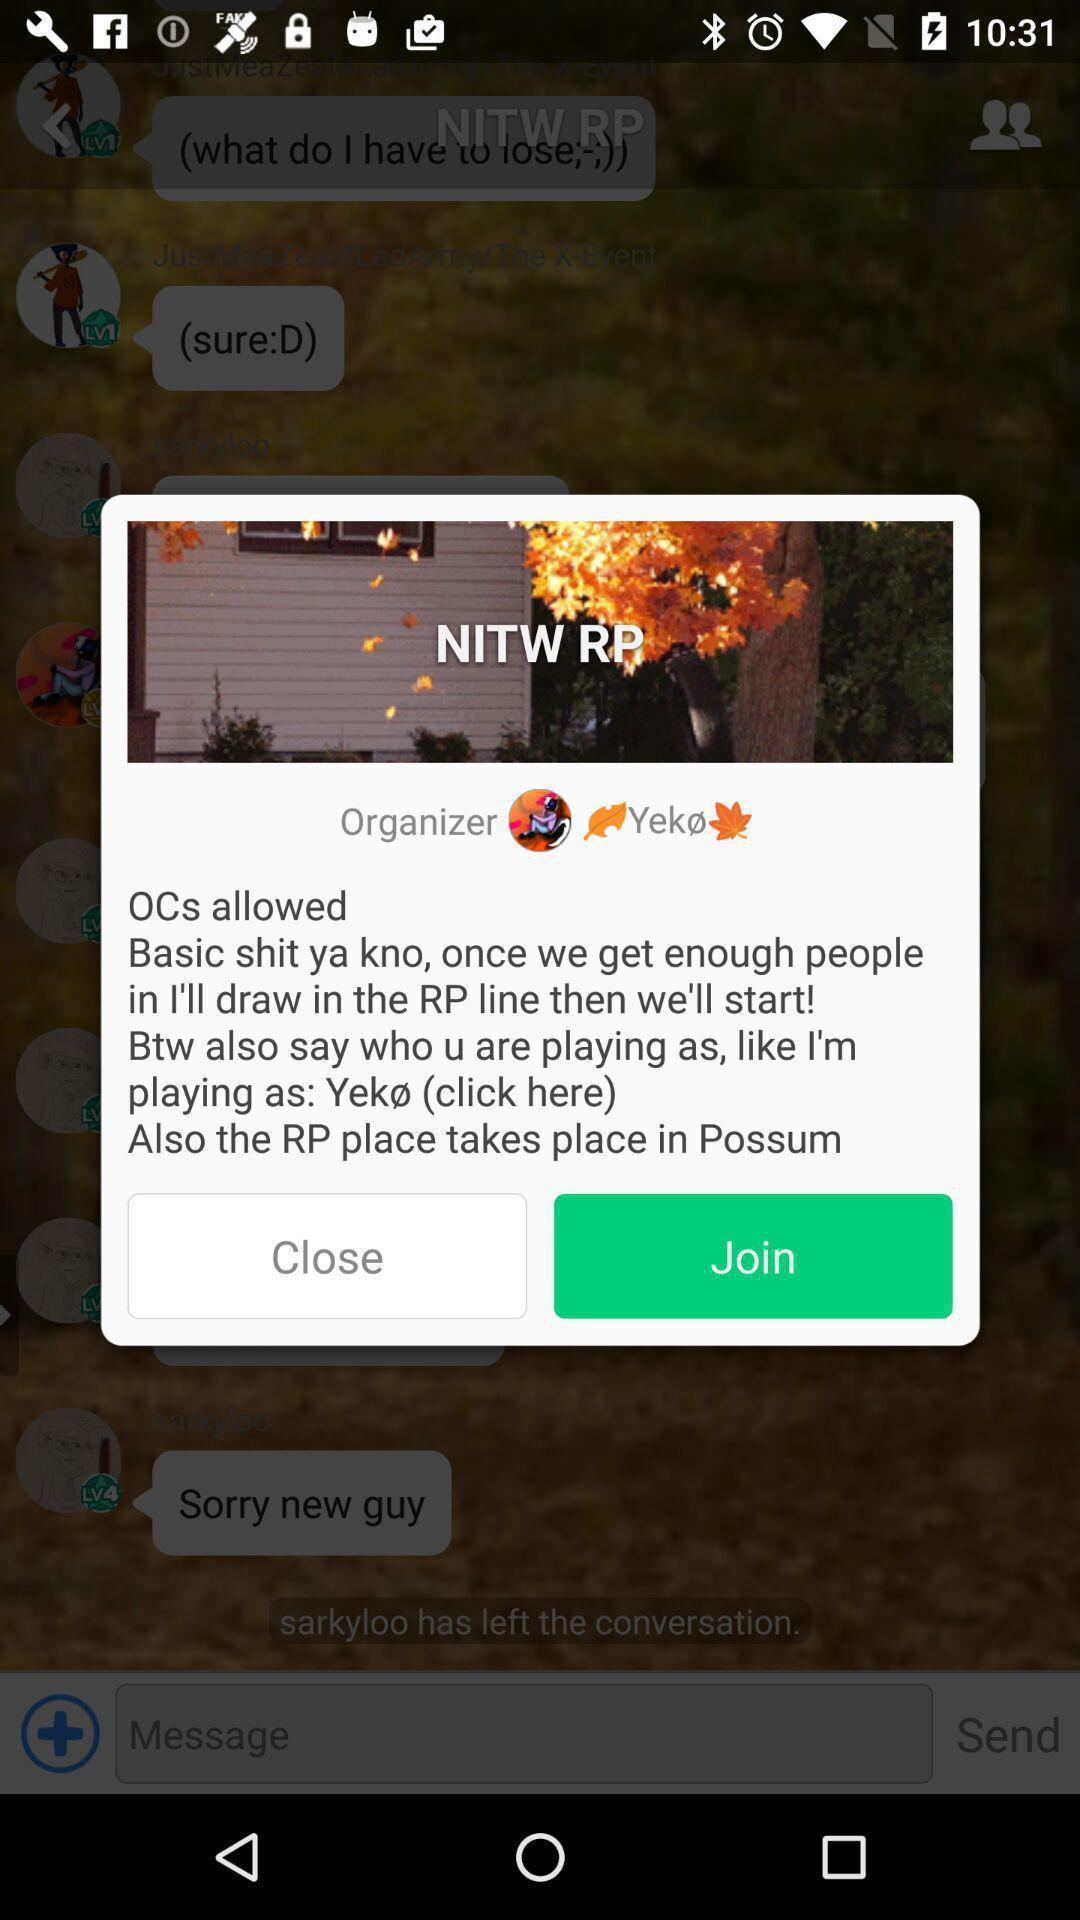What details can you identify in this image? Pop-up message displaying to join. 